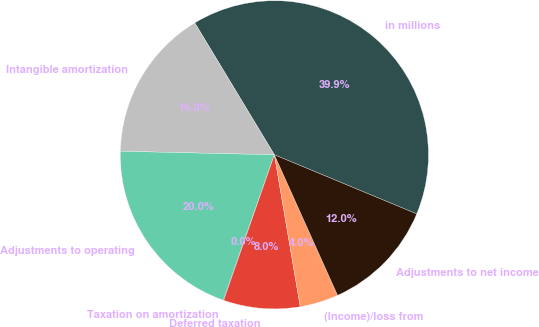Convert chart to OTSL. <chart><loc_0><loc_0><loc_500><loc_500><pie_chart><fcel>in millions<fcel>Intangible amortization<fcel>Adjustments to operating<fcel>Taxation on amortization<fcel>Deferred taxation<fcel>(Income)/loss from<fcel>Adjustments to net income<nl><fcel>39.91%<fcel>15.99%<fcel>19.98%<fcel>0.05%<fcel>8.02%<fcel>4.04%<fcel>12.01%<nl></chart> 